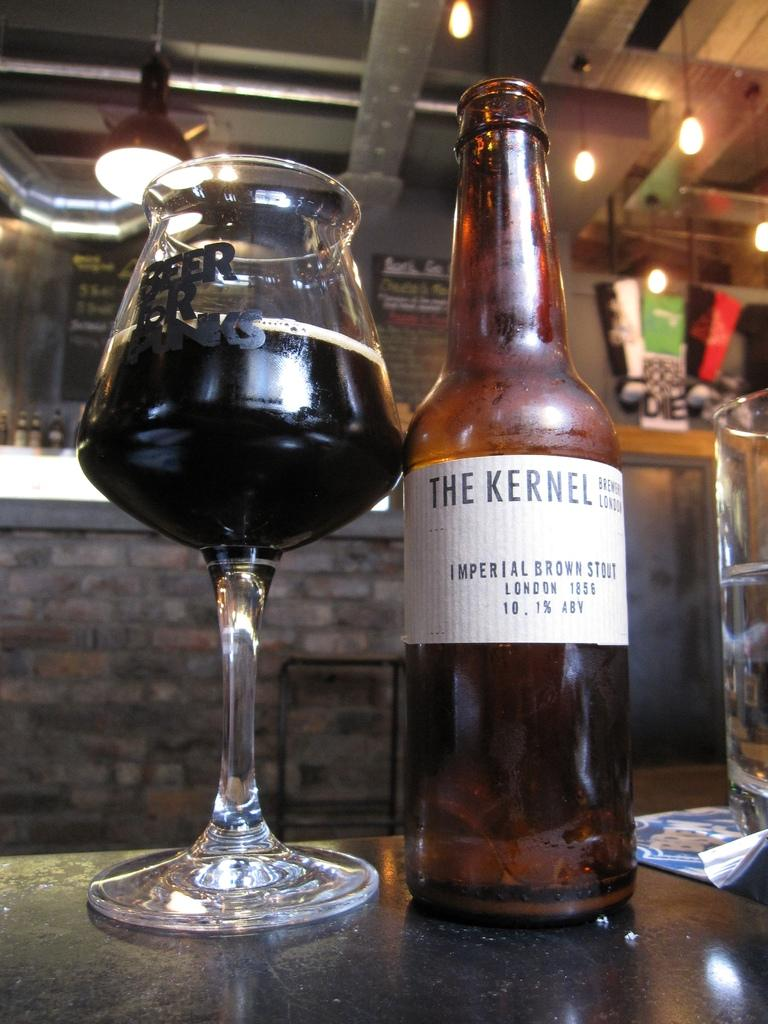What piece of furniture is present in the image? There is a table in the image. What is placed on the table? There is a wine glass and a bottle on the table. Can you describe the bottle? The bottle has a sticker on it. What can be seen in the background of the image? In the background, there are lights and a pillar visible. What degree does the basin have in the image? There is no basin present in the image, so it is not possible to determine its degree. 